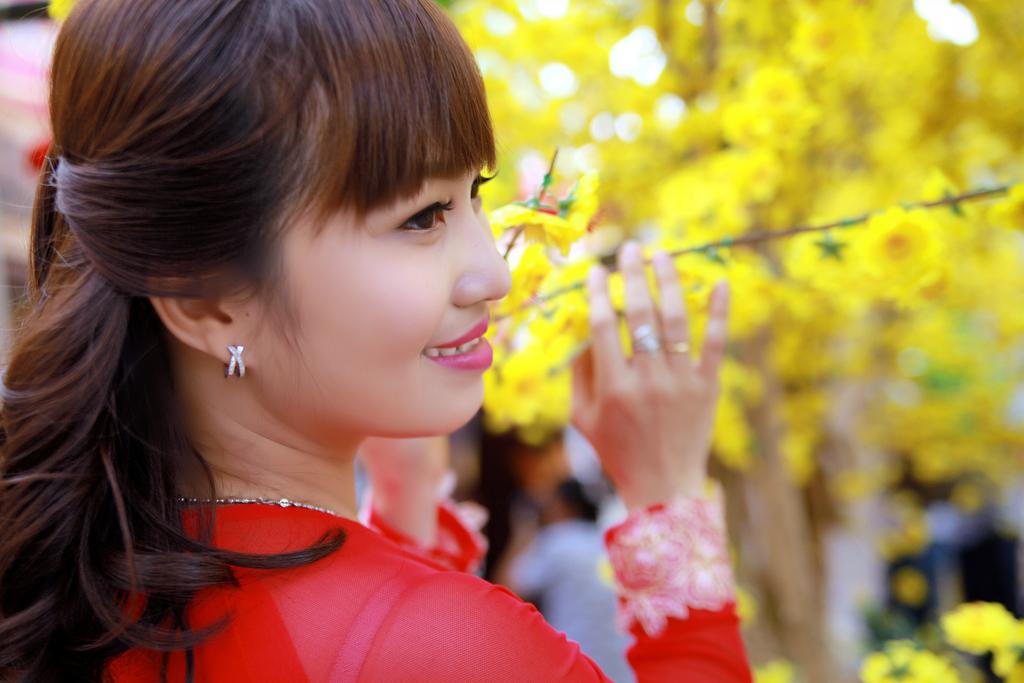What is the nationality of the girl in the image? The girl in the image is Chinese. What is the girl wearing? The girl is wearing a red dress. What is the girl's facial expression? The girl is smiling. In which direction is the girl looking? The girl is looking to the right. Can you describe the background of the image? The background is blurred, but yellow color flowers are present in the background. What type of button is the girl holding in her hand in the image? There is no button present in the image; the girl is not holding anything in her hand. What day of the week is depicted in the image? The day of the week is not mentioned or depicted in the image. 